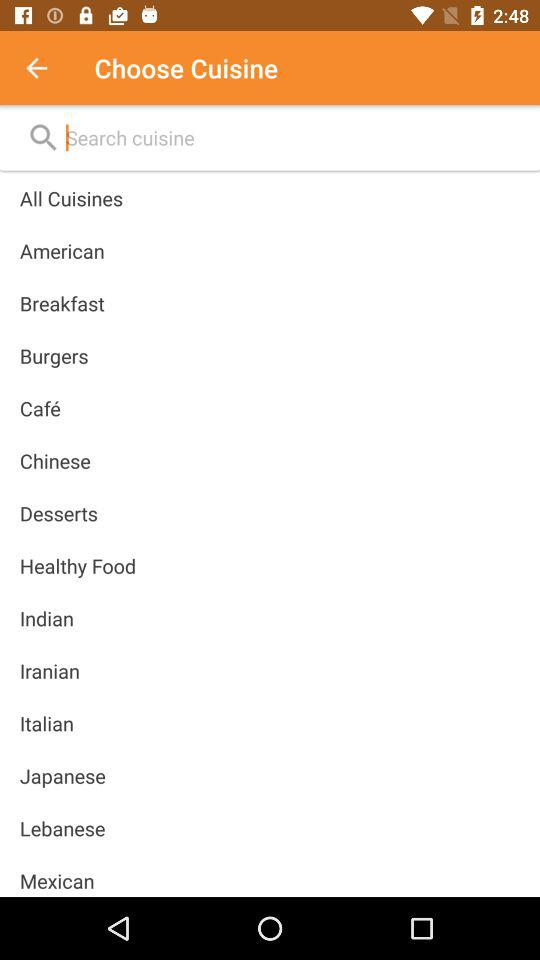What are the names of the different types of cuisines shown in the list? The different types of cuisines are "American", "Breakfast", "Burgers", "Café", "Chinese", "Desserts", "Healthy Food", "Indian", "Iranian", "Italian", "Japanese", "Lebanese", and "Mexican". 